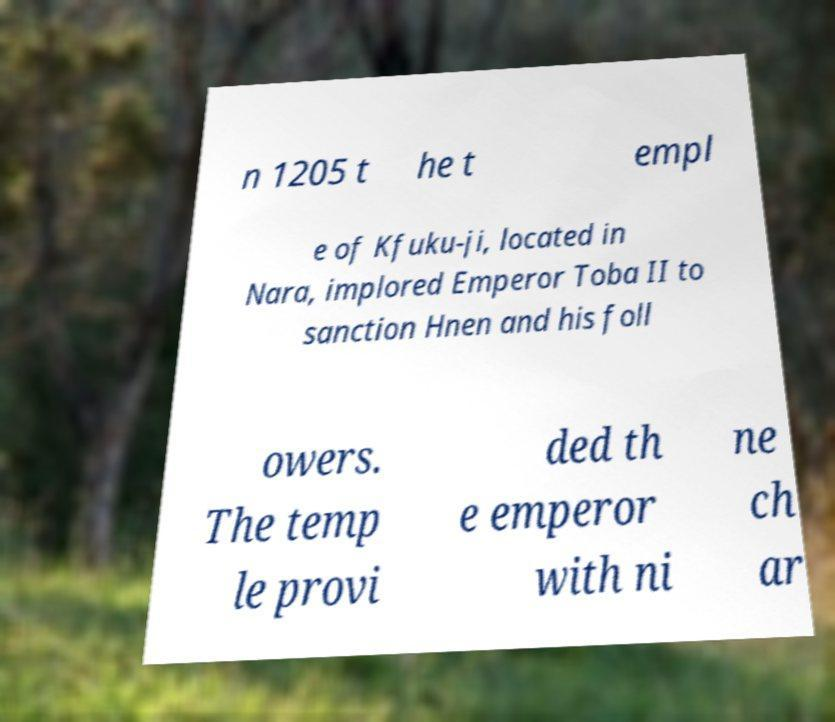I need the written content from this picture converted into text. Can you do that? n 1205 t he t empl e of Kfuku-ji, located in Nara, implored Emperor Toba II to sanction Hnen and his foll owers. The temp le provi ded th e emperor with ni ne ch ar 